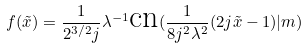<formula> <loc_0><loc_0><loc_500><loc_500>f ( \tilde { x } ) = \frac { 1 } { 2 ^ { 3 / 2 } j } \lambda ^ { - 1 } \text {cn} ( \frac { 1 } { 8 j ^ { 2 } \lambda ^ { 2 } } ( 2 j \tilde { x } - 1 ) | m )</formula> 